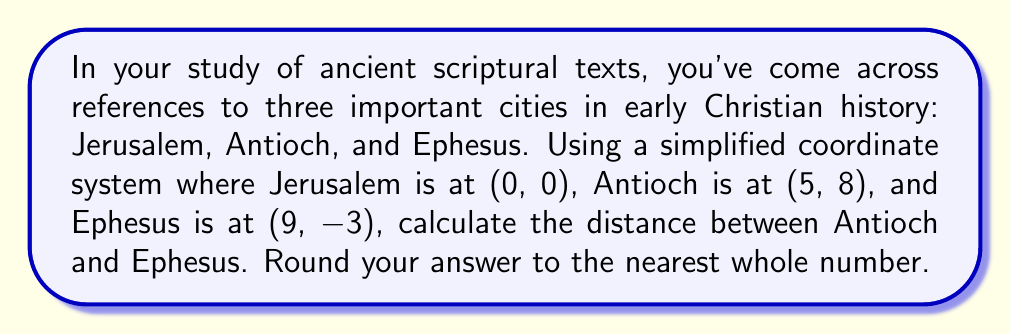Could you help me with this problem? To solve this problem, we'll use the distance formula derived from the Pythagorean theorem. The distance formula for two points $(x_1, y_1)$ and $(x_2, y_2)$ is:

$$d = \sqrt{(x_2 - x_1)^2 + (y_2 - y_1)^2}$$

Let's identify our points:
Antioch: $(x_1, y_1) = (5, 8)$
Ephesus: $(x_2, y_2) = (9, -3)$

Now, let's substitute these values into the formula:

$$\begin{align*}
d &= \sqrt{(9 - 5)^2 + (-3 - 8)^2} \\
&= \sqrt{4^2 + (-11)^2} \\
&= \sqrt{16 + 121} \\
&= \sqrt{137} \\
&\approx 11.7046...
\end{align*}$$

Rounding to the nearest whole number, we get 12.

This distance represents the straight-line distance between Antioch and Ephesus in our simplified coordinate system. In reality, the distance and route between these ancient cities would have been influenced by geography, roads, and sea routes, which were crucial for the spread of early Christian teachings and the journeys of figures like Paul the Apostle.
Answer: 12 units 